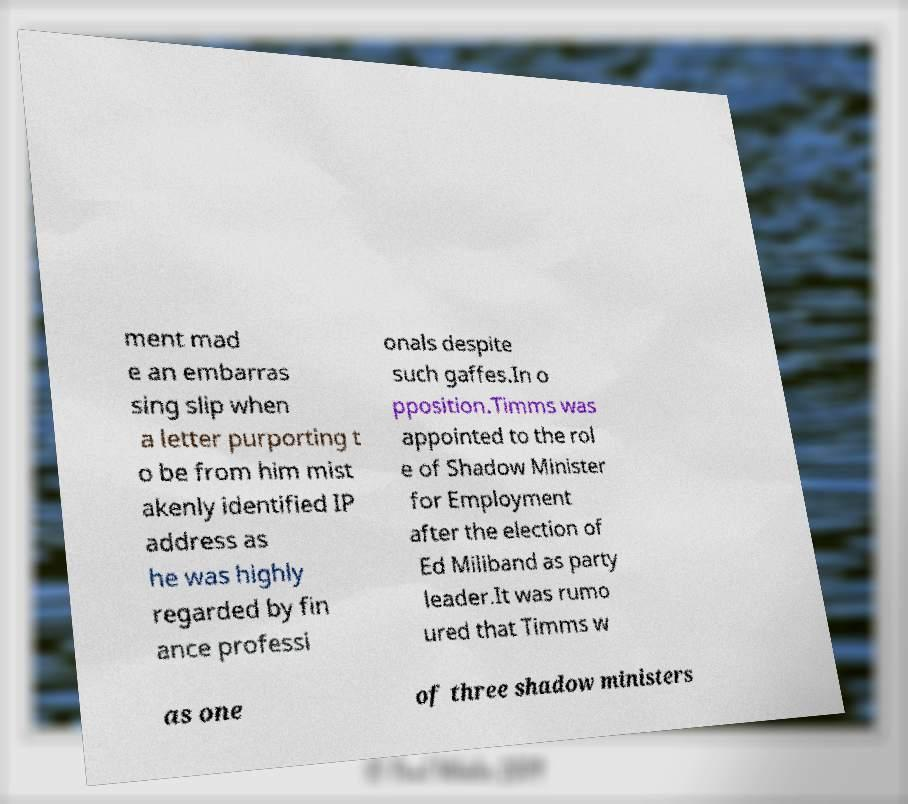What messages or text are displayed in this image? I need them in a readable, typed format. ment mad e an embarras sing slip when a letter purporting t o be from him mist akenly identified IP address as he was highly regarded by fin ance professi onals despite such gaffes.In o pposition.Timms was appointed to the rol e of Shadow Minister for Employment after the election of Ed Miliband as party leader.It was rumo ured that Timms w as one of three shadow ministers 